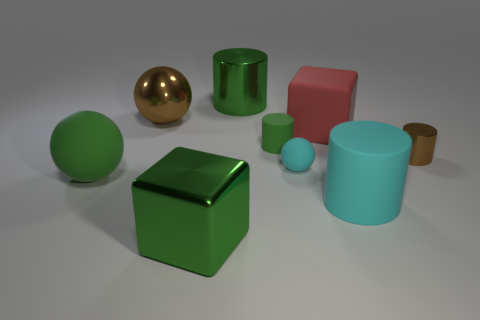Subtract 1 cylinders. How many cylinders are left? 3 Add 1 tiny blue matte balls. How many objects exist? 10 Subtract all cubes. How many objects are left? 7 Add 5 small green cylinders. How many small green cylinders exist? 6 Subtract 1 green balls. How many objects are left? 8 Subtract all small brown cylinders. Subtract all green things. How many objects are left? 4 Add 8 tiny matte balls. How many tiny matte balls are left? 9 